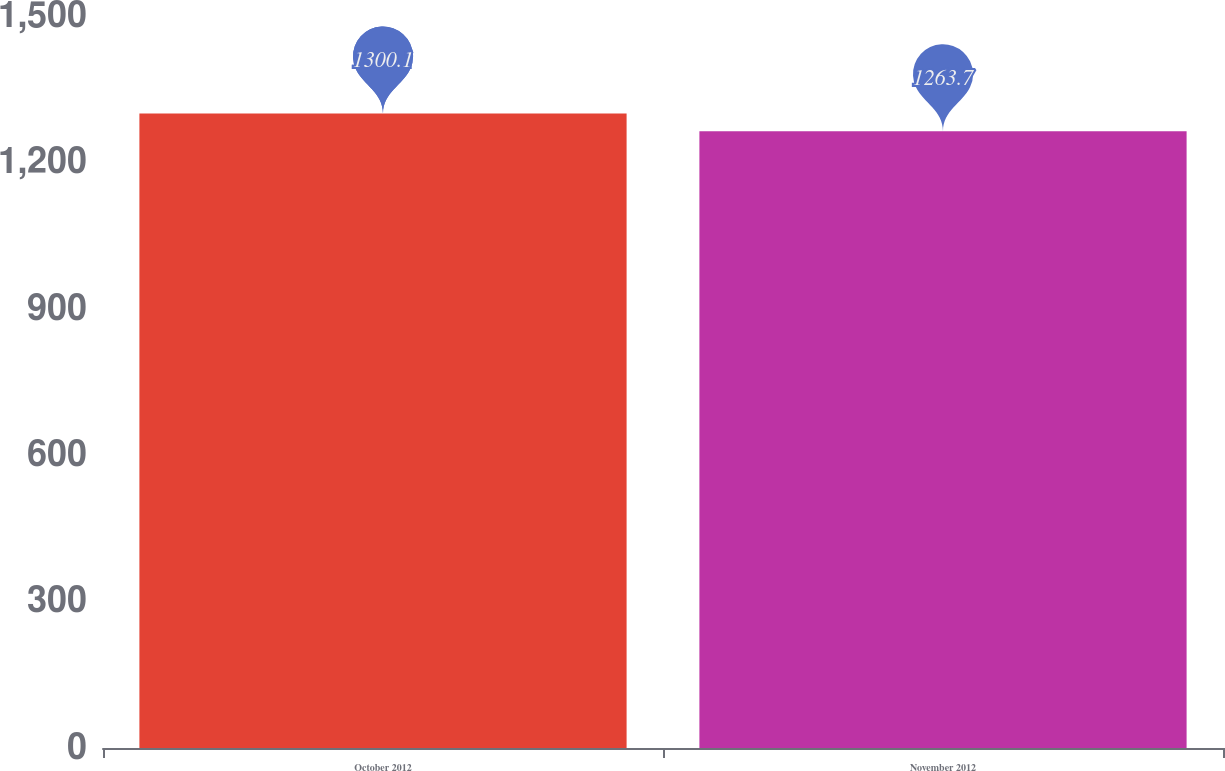Convert chart. <chart><loc_0><loc_0><loc_500><loc_500><bar_chart><fcel>October 2012<fcel>November 2012<nl><fcel>1300.1<fcel>1263.7<nl></chart> 